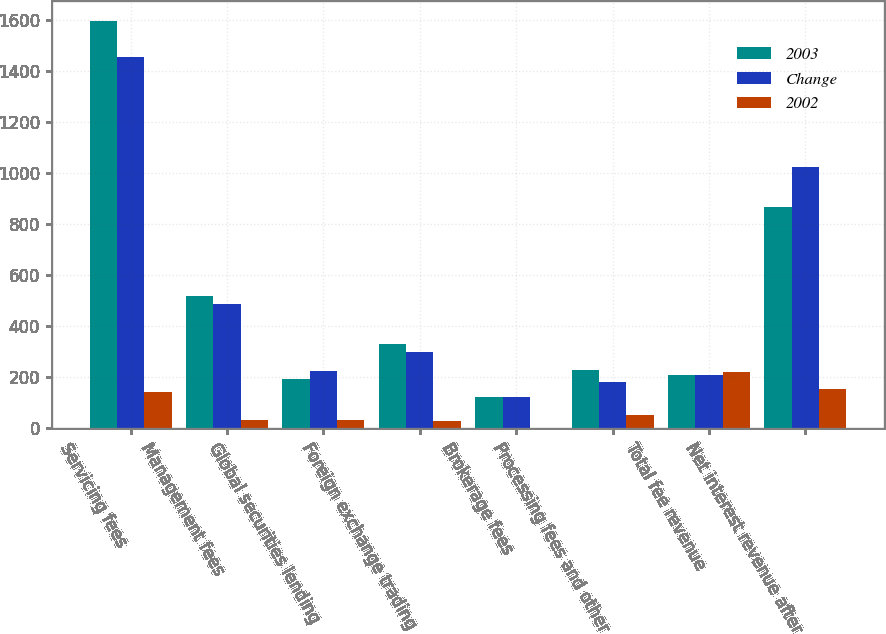Convert chart to OTSL. <chart><loc_0><loc_0><loc_500><loc_500><stacked_bar_chart><ecel><fcel>Servicing fees<fcel>Management fees<fcel>Global securities lending<fcel>Foreign exchange trading<fcel>Brokerage fees<fcel>Processing fees and other<fcel>Total fee revenue<fcel>Net interest revenue after<nl><fcel>2003<fcel>1596<fcel>517<fcel>194<fcel>330<fcel>122<fcel>230<fcel>207<fcel>868<nl><fcel>Change<fcel>1454<fcel>485<fcel>226<fcel>300<fcel>124<fcel>180<fcel>207<fcel>1023<nl><fcel>2002<fcel>142<fcel>32<fcel>32<fcel>30<fcel>2<fcel>50<fcel>220<fcel>155<nl></chart> 